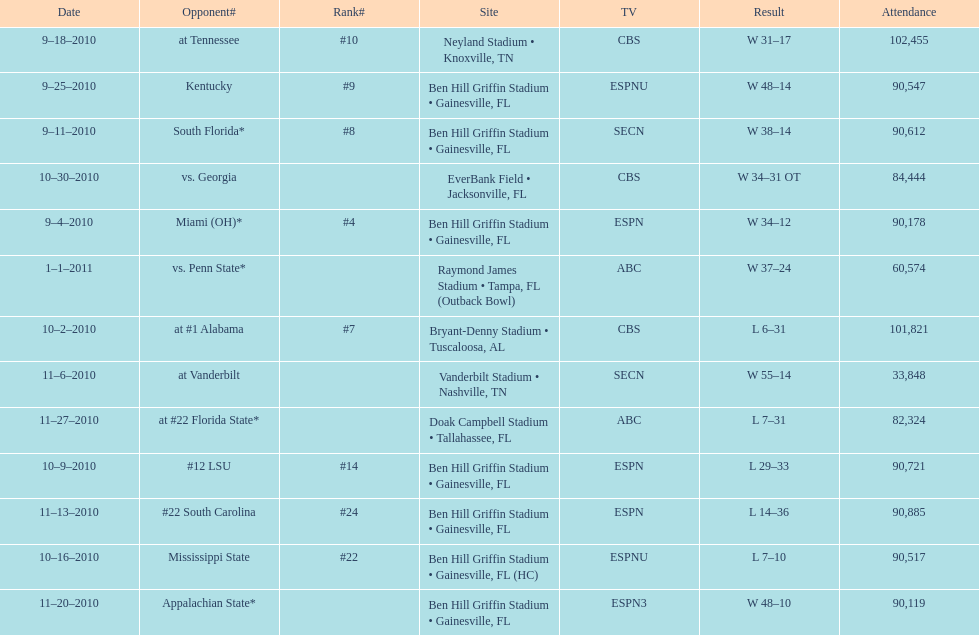The gators won the game on september 25, 2010. who won the previous game? Gators. 